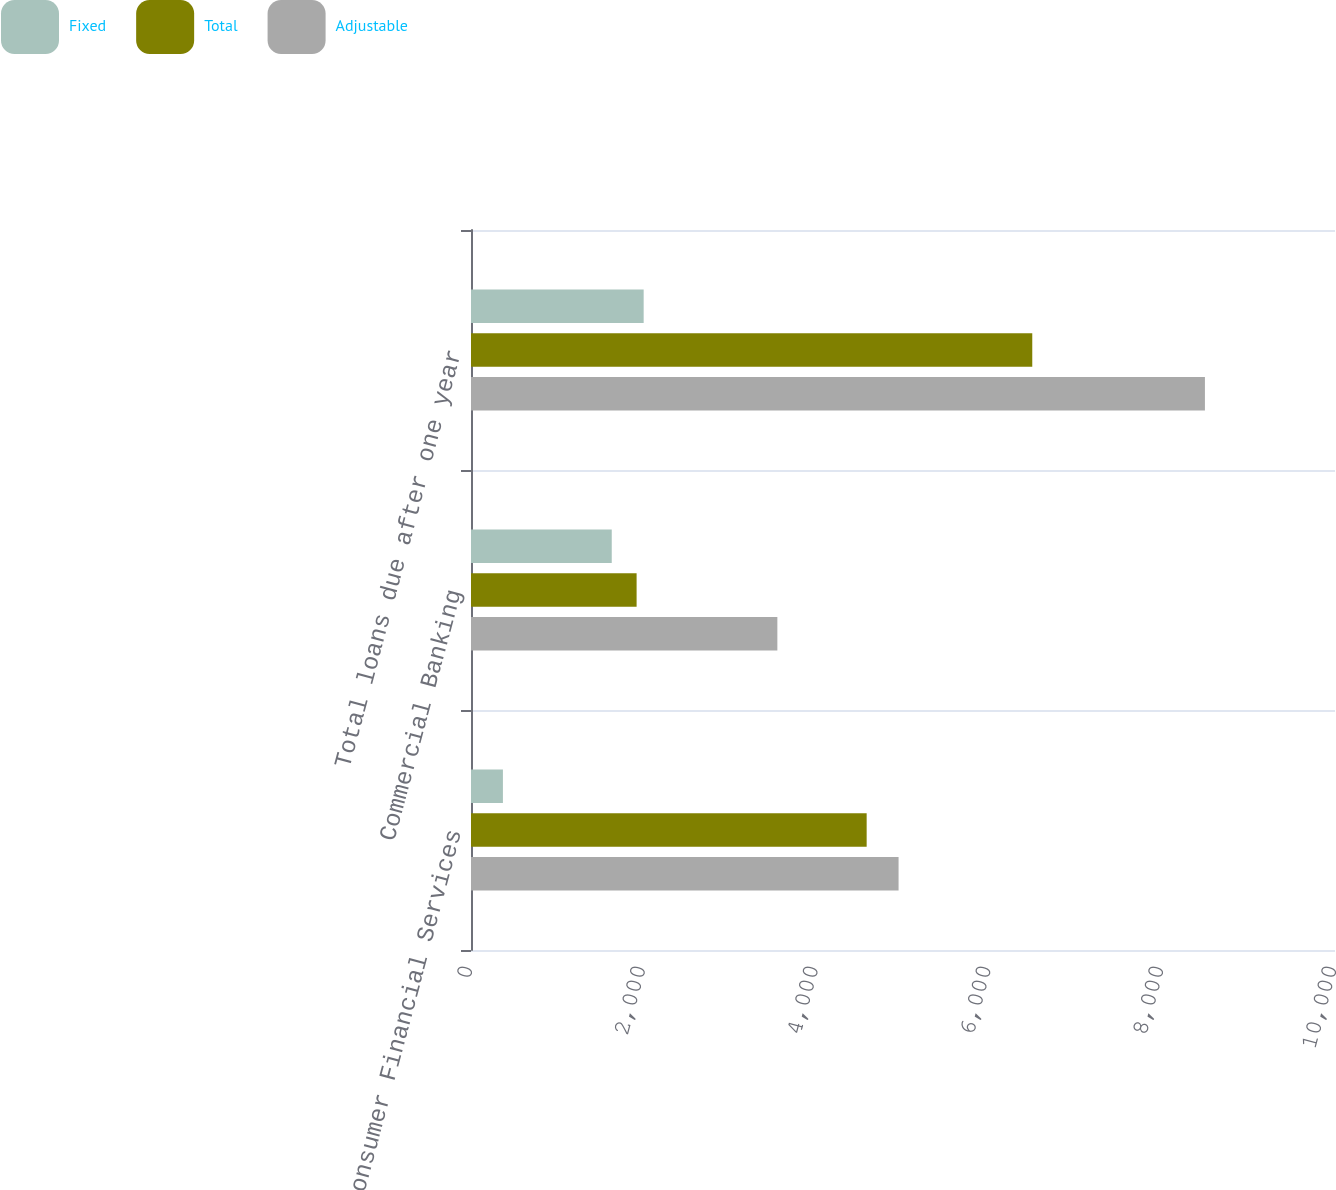<chart> <loc_0><loc_0><loc_500><loc_500><stacked_bar_chart><ecel><fcel>Consumer Financial Services<fcel>Commercial Banking<fcel>Total loans due after one year<nl><fcel>Fixed<fcel>369.4<fcel>1629<fcel>1998.4<nl><fcel>Total<fcel>4579.4<fcel>1916.8<fcel>6496.2<nl><fcel>Adjustable<fcel>4948.8<fcel>3545.8<fcel>8494.6<nl></chart> 